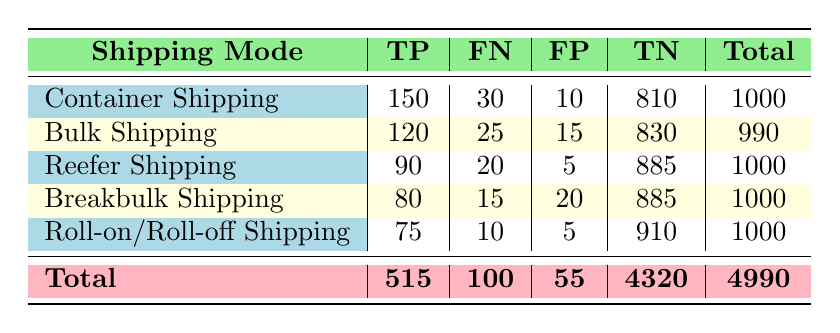What is the total number of true positives across all shipping modes? To find the total number of true positives, we sum the true positive values (TP) from each mode: 150 (Container) + 120 (Bulk) + 90 (Reefer) + 80 (Breakbulk) + 75 (Roll-on/Roll-off) = 515.
Answer: 515 What is the highest number of false negatives in a single shipping mode? Looking at the false negative values (FN) for each mode: 30 (Container), 25 (Bulk), 20 (Reefer), 15 (Breakbulk), 10 (Roll-on/Roll-off). The highest value is 30 for Container Shipping.
Answer: 30 Is the number of true negatives for Breakbulk Shipping greater than the number of true positives? The true positive value for Breakbulk is 80, and the true negative value is 885. Since 885 is greater than 80, the statement is true.
Answer: Yes What is the combined number of false positives for Reefer and Bulk Shipping? To find the combined false positives (FP), we add the FP of Reefer (5) and Bulk (15): 5 + 15 = 20.
Answer: 20 Which shipping mode has the lowest total incidents (both damages and timely deliveries)? The total incidents for each mode can be obtained from the last column of the table which shows 1000 for each of Container, Reefer, Breakbulk and Roll-on/Roll-off. However, for Bulk Shipping, it shows 990, which is lower than the others.
Answer: Bulk Shipping What percentage of incidents in Reefer Shipping are false negatives? To calculate this, we use the formula: (False Negatives / Total) * 100. The number of false negatives in Reefer Shipping is 20 and the total is 1000, so: (20 / 1000) * 100 = 2%.
Answer: 2% Is the total number of false positives across all shipping modes less than the total number of false negatives? First, we calculate the total false positives: 10 (Container) + 15 (Bulk) + 5 (Reefer) + 20 (Breakbulk) + 5 (Roll-on/Roll-off) = 55. The total false negatives are 100. Since 55 is less than 100, the answer is true.
Answer: Yes Which shipping mode has the best ratio of true positives to false negatives? We calculate the ratio for each mode: Container (150/30), Bulk (120/25), Reefer (90/20), Breakbulk (80/15), and Roll-on/Roll-off (75/10). The ratios are 5, 4.8, 4.5, 5.33, and 7.5 respectively. The best ratio is for Roll-on/Roll-off at 7.5.
Answer: Roll-on/Roll-off 